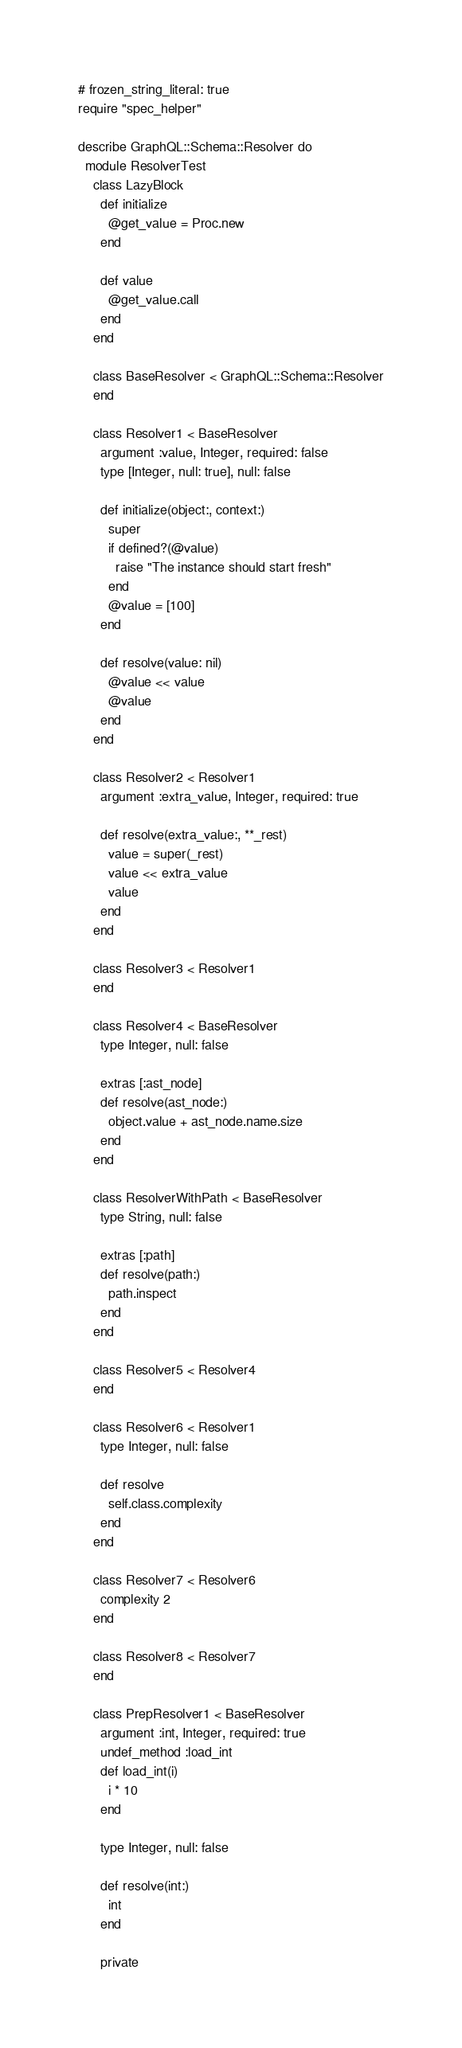Convert code to text. <code><loc_0><loc_0><loc_500><loc_500><_Ruby_># frozen_string_literal: true
require "spec_helper"

describe GraphQL::Schema::Resolver do
  module ResolverTest
    class LazyBlock
      def initialize
        @get_value = Proc.new
      end

      def value
        @get_value.call
      end
    end

    class BaseResolver < GraphQL::Schema::Resolver
    end

    class Resolver1 < BaseResolver
      argument :value, Integer, required: false
      type [Integer, null: true], null: false

      def initialize(object:, context:)
        super
        if defined?(@value)
          raise "The instance should start fresh"
        end
        @value = [100]
      end

      def resolve(value: nil)
        @value << value
        @value
      end
    end

    class Resolver2 < Resolver1
      argument :extra_value, Integer, required: true

      def resolve(extra_value:, **_rest)
        value = super(_rest)
        value << extra_value
        value
      end
    end

    class Resolver3 < Resolver1
    end

    class Resolver4 < BaseResolver
      type Integer, null: false

      extras [:ast_node]
      def resolve(ast_node:)
        object.value + ast_node.name.size
      end
    end

    class ResolverWithPath < BaseResolver
      type String, null: false

      extras [:path]
      def resolve(path:)
        path.inspect
      end
    end

    class Resolver5 < Resolver4
    end

    class Resolver6 < Resolver1
      type Integer, null: false

      def resolve
        self.class.complexity
      end
    end

    class Resolver7 < Resolver6
      complexity 2
    end

    class Resolver8 < Resolver7
    end

    class PrepResolver1 < BaseResolver
      argument :int, Integer, required: true
      undef_method :load_int
      def load_int(i)
        i * 10
      end

      type Integer, null: false

      def resolve(int:)
        int
      end

      private
</code> 